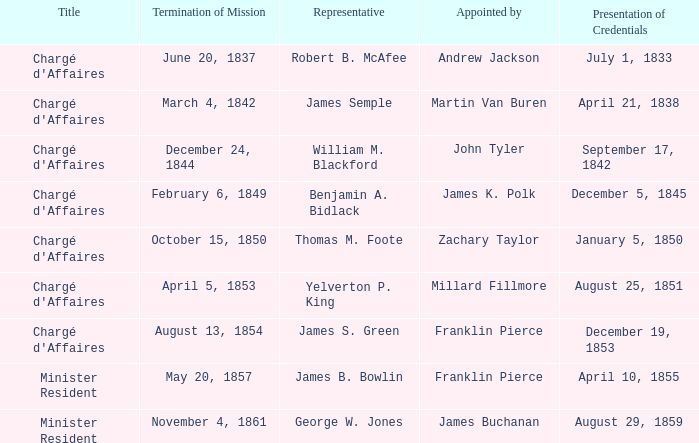What Representative has a Presentation of Credentails of April 10, 1855? James B. Bowlin. 